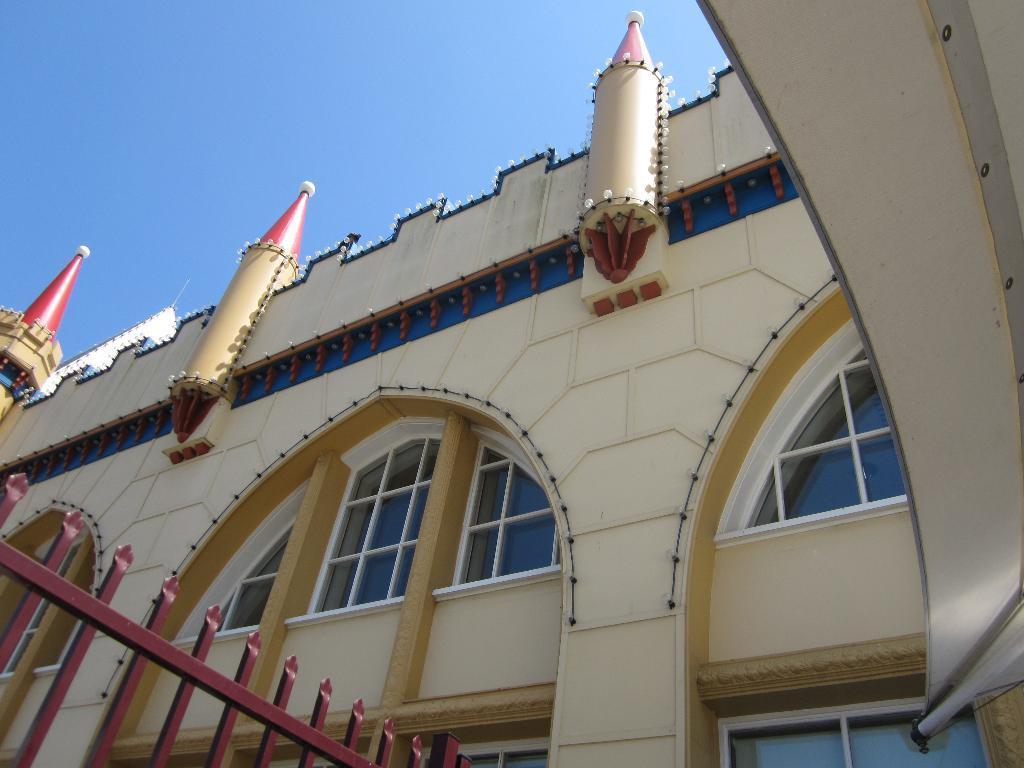How would you summarize this image in a sentence or two? In this image we can see a building and there is a fence at the bottom and at the top we can see the sky. 